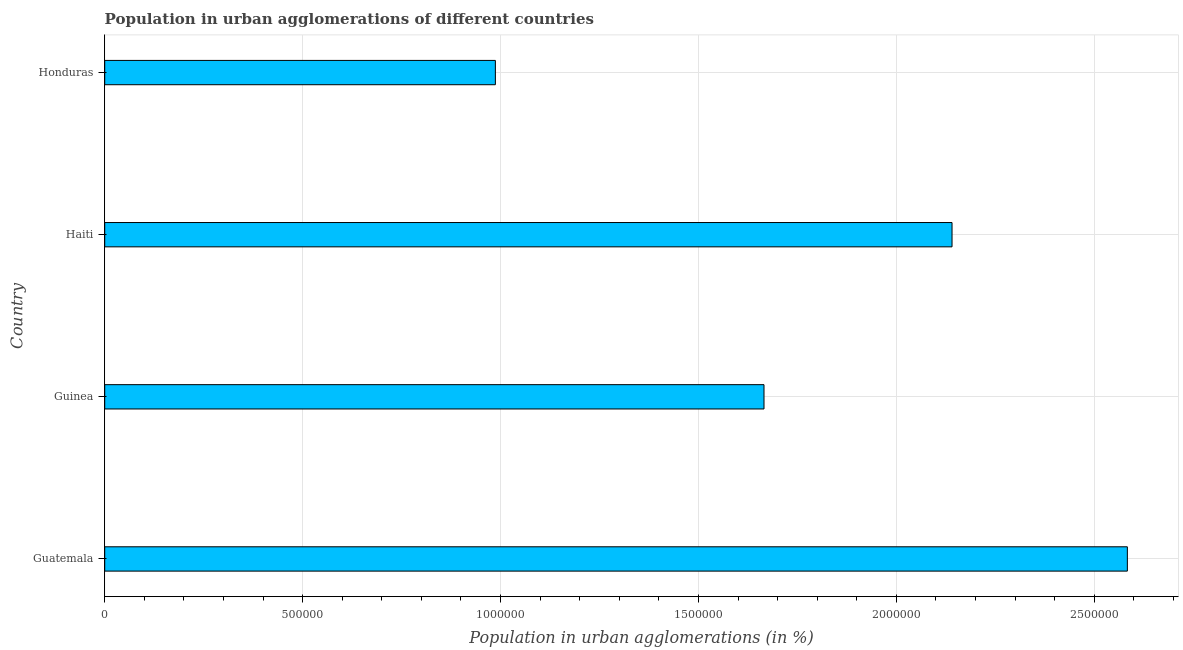What is the title of the graph?
Your response must be concise. Population in urban agglomerations of different countries. What is the label or title of the X-axis?
Offer a terse response. Population in urban agglomerations (in %). What is the population in urban agglomerations in Haiti?
Offer a very short reply. 2.14e+06. Across all countries, what is the maximum population in urban agglomerations?
Your answer should be very brief. 2.58e+06. Across all countries, what is the minimum population in urban agglomerations?
Make the answer very short. 9.87e+05. In which country was the population in urban agglomerations maximum?
Ensure brevity in your answer.  Guatemala. In which country was the population in urban agglomerations minimum?
Give a very brief answer. Honduras. What is the sum of the population in urban agglomerations?
Your response must be concise. 7.38e+06. What is the difference between the population in urban agglomerations in Haiti and Honduras?
Offer a terse response. 1.15e+06. What is the average population in urban agglomerations per country?
Give a very brief answer. 1.84e+06. What is the median population in urban agglomerations?
Keep it short and to the point. 1.90e+06. In how many countries, is the population in urban agglomerations greater than 2400000 %?
Your answer should be compact. 1. What is the ratio of the population in urban agglomerations in Guatemala to that in Honduras?
Keep it short and to the point. 2.62. Is the population in urban agglomerations in Guatemala less than that in Haiti?
Make the answer very short. No. Is the difference between the population in urban agglomerations in Haiti and Honduras greater than the difference between any two countries?
Your response must be concise. No. What is the difference between the highest and the second highest population in urban agglomerations?
Your answer should be very brief. 4.43e+05. What is the difference between the highest and the lowest population in urban agglomerations?
Offer a terse response. 1.60e+06. How many bars are there?
Provide a succinct answer. 4. Are all the bars in the graph horizontal?
Offer a terse response. Yes. Are the values on the major ticks of X-axis written in scientific E-notation?
Your answer should be compact. No. What is the Population in urban agglomerations (in %) of Guatemala?
Provide a succinct answer. 2.58e+06. What is the Population in urban agglomerations (in %) in Guinea?
Your response must be concise. 1.67e+06. What is the Population in urban agglomerations (in %) of Haiti?
Ensure brevity in your answer.  2.14e+06. What is the Population in urban agglomerations (in %) in Honduras?
Your answer should be very brief. 9.87e+05. What is the difference between the Population in urban agglomerations (in %) in Guatemala and Guinea?
Offer a very short reply. 9.18e+05. What is the difference between the Population in urban agglomerations (in %) in Guatemala and Haiti?
Ensure brevity in your answer.  4.43e+05. What is the difference between the Population in urban agglomerations (in %) in Guatemala and Honduras?
Give a very brief answer. 1.60e+06. What is the difference between the Population in urban agglomerations (in %) in Guinea and Haiti?
Give a very brief answer. -4.75e+05. What is the difference between the Population in urban agglomerations (in %) in Guinea and Honduras?
Keep it short and to the point. 6.79e+05. What is the difference between the Population in urban agglomerations (in %) in Haiti and Honduras?
Provide a short and direct response. 1.15e+06. What is the ratio of the Population in urban agglomerations (in %) in Guatemala to that in Guinea?
Your answer should be compact. 1.55. What is the ratio of the Population in urban agglomerations (in %) in Guatemala to that in Haiti?
Your answer should be compact. 1.21. What is the ratio of the Population in urban agglomerations (in %) in Guatemala to that in Honduras?
Give a very brief answer. 2.62. What is the ratio of the Population in urban agglomerations (in %) in Guinea to that in Haiti?
Provide a short and direct response. 0.78. What is the ratio of the Population in urban agglomerations (in %) in Guinea to that in Honduras?
Your response must be concise. 1.69. What is the ratio of the Population in urban agglomerations (in %) in Haiti to that in Honduras?
Give a very brief answer. 2.17. 